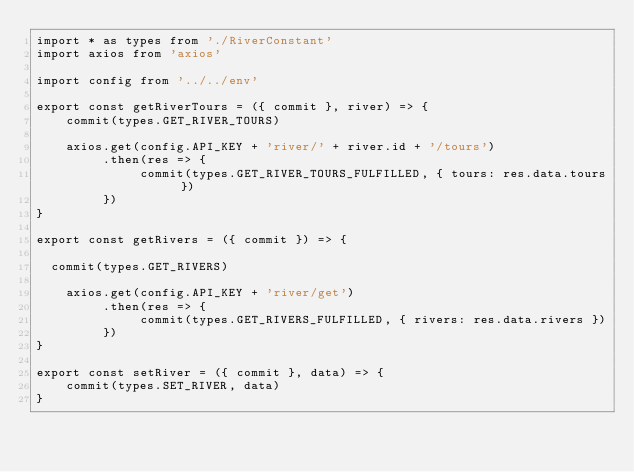<code> <loc_0><loc_0><loc_500><loc_500><_JavaScript_>import * as types from './RiverConstant'
import axios from 'axios'

import config from '../../env'

export const getRiverTours = ({ commit }, river) => {
    commit(types.GET_RIVER_TOURS)

    axios.get(config.API_KEY + 'river/' + river.id + '/tours')
         .then(res => {
              commit(types.GET_RIVER_TOURS_FULFILLED, { tours: res.data.tours })
         })
}

export const getRivers = ({ commit }) => {

	commit(types.GET_RIVERS)

    axios.get(config.API_KEY + 'river/get')
         .then(res => {
              commit(types.GET_RIVERS_FULFILLED, { rivers: res.data.rivers })
         })
}

export const setRiver = ({ commit }, data) => {
    commit(types.SET_RIVER, data)
}</code> 